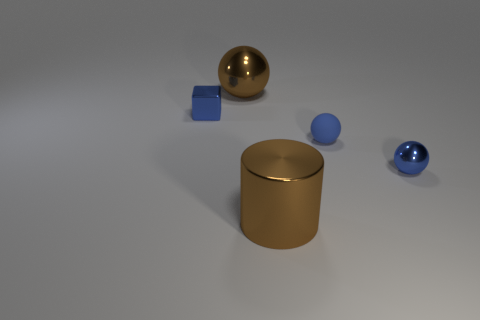There is a blue metallic object to the left of the blue metallic thing on the right side of the large brown cylinder; what is its shape?
Your answer should be very brief. Cube. Is the number of tiny blue metallic blocks that are right of the big metal cylinder less than the number of objects right of the small matte thing?
Give a very brief answer. Yes. There is a large shiny thing that is the same shape as the rubber object; what color is it?
Ensure brevity in your answer.  Brown. What number of small things are behind the tiny blue shiny sphere and in front of the blue cube?
Provide a succinct answer. 1. Are there more blue rubber things that are in front of the brown metal cylinder than small shiny things that are to the right of the blue rubber thing?
Offer a terse response. No. The blue rubber thing has what size?
Ensure brevity in your answer.  Small. Are there any brown objects that have the same shape as the blue matte thing?
Give a very brief answer. Yes. Does the blue rubber thing have the same shape as the large brown thing behind the blue metallic sphere?
Make the answer very short. Yes. What size is the object that is both on the left side of the metallic cylinder and in front of the large sphere?
Your answer should be compact. Small. How many cyan objects are there?
Give a very brief answer. 0. 